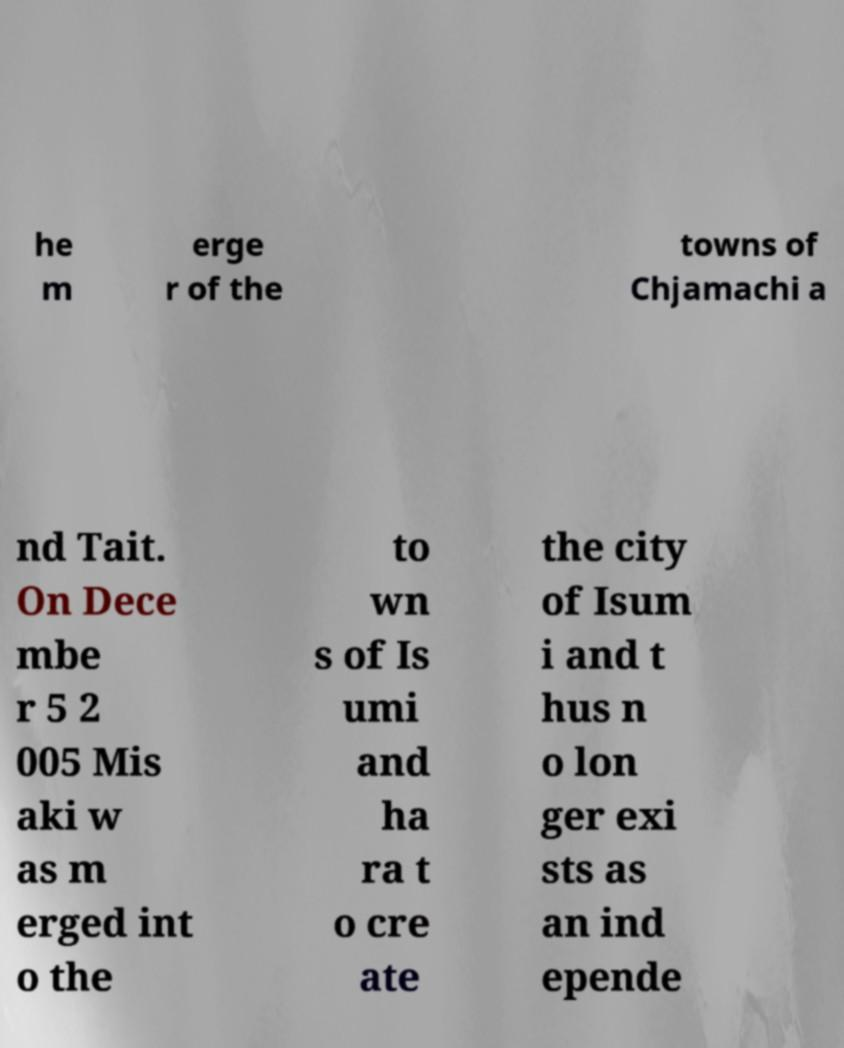Could you extract and type out the text from this image? he m erge r of the towns of Chjamachi a nd Tait. On Dece mbe r 5 2 005 Mis aki w as m erged int o the to wn s of Is umi and ha ra t o cre ate the city of Isum i and t hus n o lon ger exi sts as an ind epende 